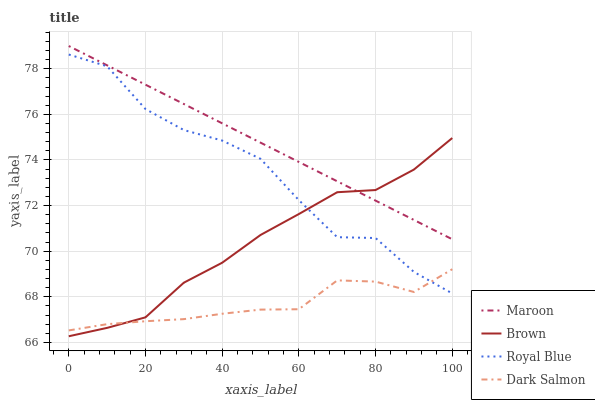Does Maroon have the minimum area under the curve?
Answer yes or no. No. Does Dark Salmon have the maximum area under the curve?
Answer yes or no. No. Is Dark Salmon the smoothest?
Answer yes or no. No. Is Dark Salmon the roughest?
Answer yes or no. No. Does Dark Salmon have the lowest value?
Answer yes or no. No. Does Dark Salmon have the highest value?
Answer yes or no. No. Is Dark Salmon less than Maroon?
Answer yes or no. Yes. Is Maroon greater than Royal Blue?
Answer yes or no. Yes. Does Dark Salmon intersect Maroon?
Answer yes or no. No. 